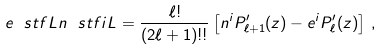<formula> <loc_0><loc_0><loc_500><loc_500>e ^ { \ } s t f { L } n ^ { \ } s t f { i L } = \frac { \ell ! } { ( 2 \ell + 1 ) ! ! } \left [ n ^ { i } P _ { \ell + 1 } ^ { \prime } ( z ) - e ^ { i } P _ { \ell } ^ { \prime } ( z ) \right ] \, ,</formula> 